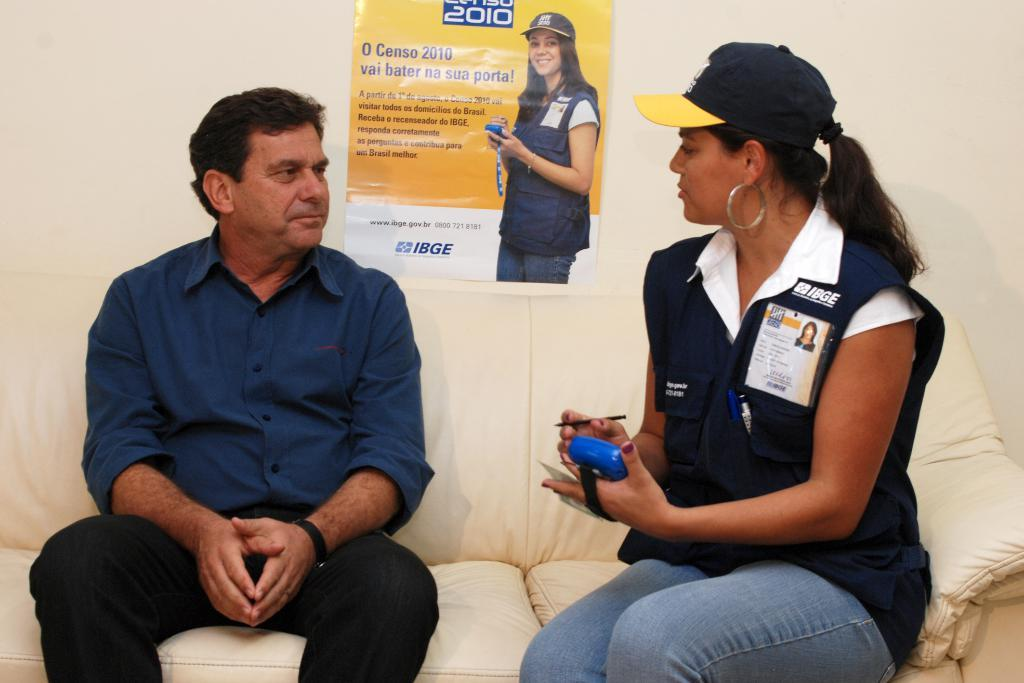What are the persons in the image doing? The persons in the image are sitting on a couch. What can be seen on the wall behind the persons? There is an advertisement pasted on the wall behind the persons. What type of development is taking place on the floor in the image? There is no development taking place on the floor in the image; it only shows persons sitting on a couch and an advertisement on the wall. 